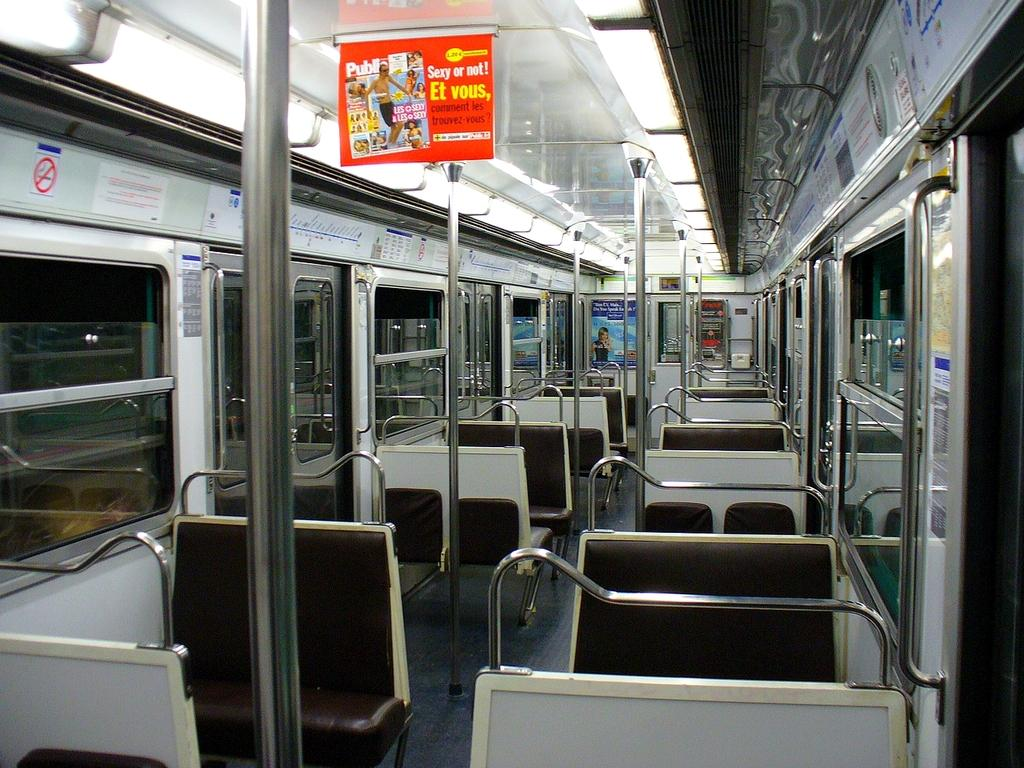<image>
Present a compact description of the photo's key features. The inside of an empty bus has an advertisement for Public magazine, Sexy or Not!. 